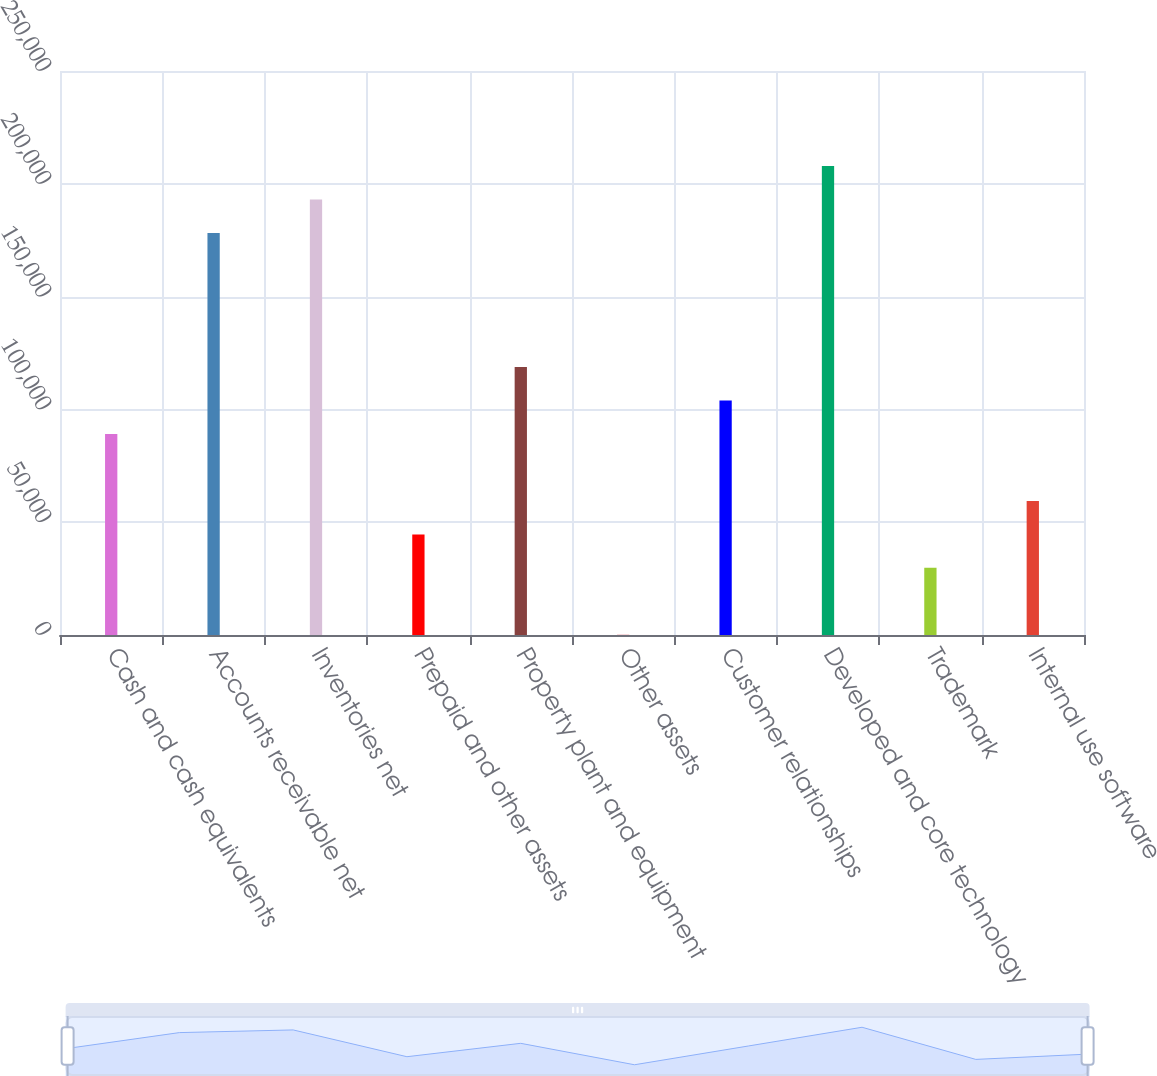Convert chart. <chart><loc_0><loc_0><loc_500><loc_500><bar_chart><fcel>Cash and cash equivalents<fcel>Accounts receivable net<fcel>Inventories net<fcel>Prepaid and other assets<fcel>Property plant and equipment<fcel>Other assets<fcel>Customer relationships<fcel>Developed and core technology<fcel>Trademark<fcel>Internal use software<nl><fcel>89135.8<fcel>178202<fcel>193046<fcel>44602.9<fcel>118824<fcel>70<fcel>103980<fcel>207890<fcel>29758.6<fcel>59447.2<nl></chart> 